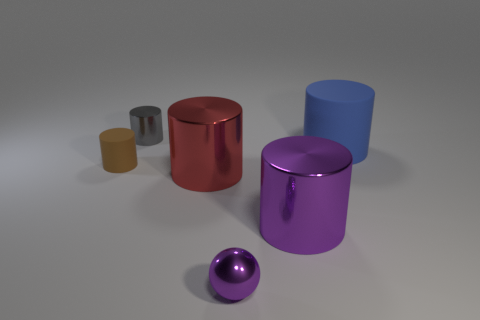There is a cylinder behind the rubber object that is behind the tiny brown matte thing; what is its color?
Make the answer very short. Gray. Are there any large metal cylinders that have the same color as the tiny metallic sphere?
Ensure brevity in your answer.  Yes. What is the size of the matte thing that is to the right of the tiny cylinder that is in front of the metallic cylinder behind the tiny brown cylinder?
Offer a very short reply. Large. Do the tiny brown object and the purple metal object left of the large purple cylinder have the same shape?
Keep it short and to the point. No. What number of other objects are the same size as the ball?
Your answer should be very brief. 2. There is a purple metallic cylinder on the left side of the large matte object; what is its size?
Your answer should be compact. Large. What number of other things have the same material as the red thing?
Make the answer very short. 3. Do the metal object left of the red shiny thing and the tiny purple object have the same shape?
Give a very brief answer. No. What shape is the small metallic object that is on the left side of the ball?
Provide a short and direct response. Cylinder. What material is the blue object?
Offer a very short reply. Rubber. 